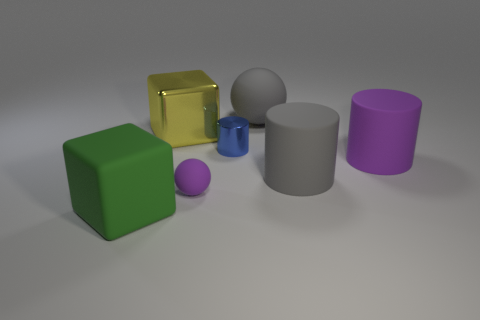Add 1 rubber cylinders. How many objects exist? 8 Subtract all balls. How many objects are left? 5 Subtract 0 red blocks. How many objects are left? 7 Subtract all green blocks. Subtract all rubber spheres. How many objects are left? 4 Add 4 large green matte blocks. How many large green matte blocks are left? 5 Add 2 big objects. How many big objects exist? 7 